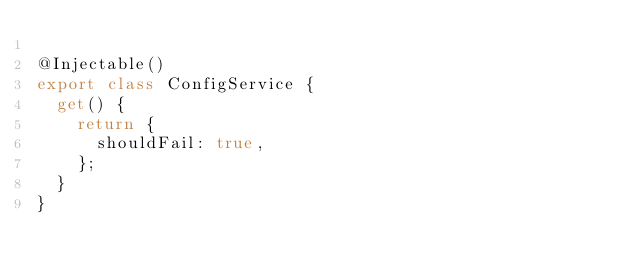<code> <loc_0><loc_0><loc_500><loc_500><_TypeScript_>
@Injectable()
export class ConfigService {
  get() {
    return {
      shouldFail: true,
    };
  }
}
</code> 